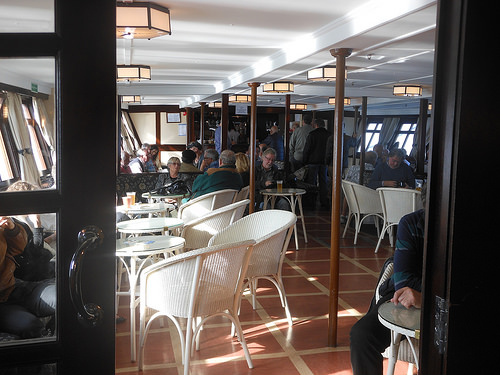<image>
Is there a chair under the ceiling? Yes. The chair is positioned underneath the ceiling, with the ceiling above it in the vertical space. Where is the chair in relation to the table? Is it next to the table? Yes. The chair is positioned adjacent to the table, located nearby in the same general area. 